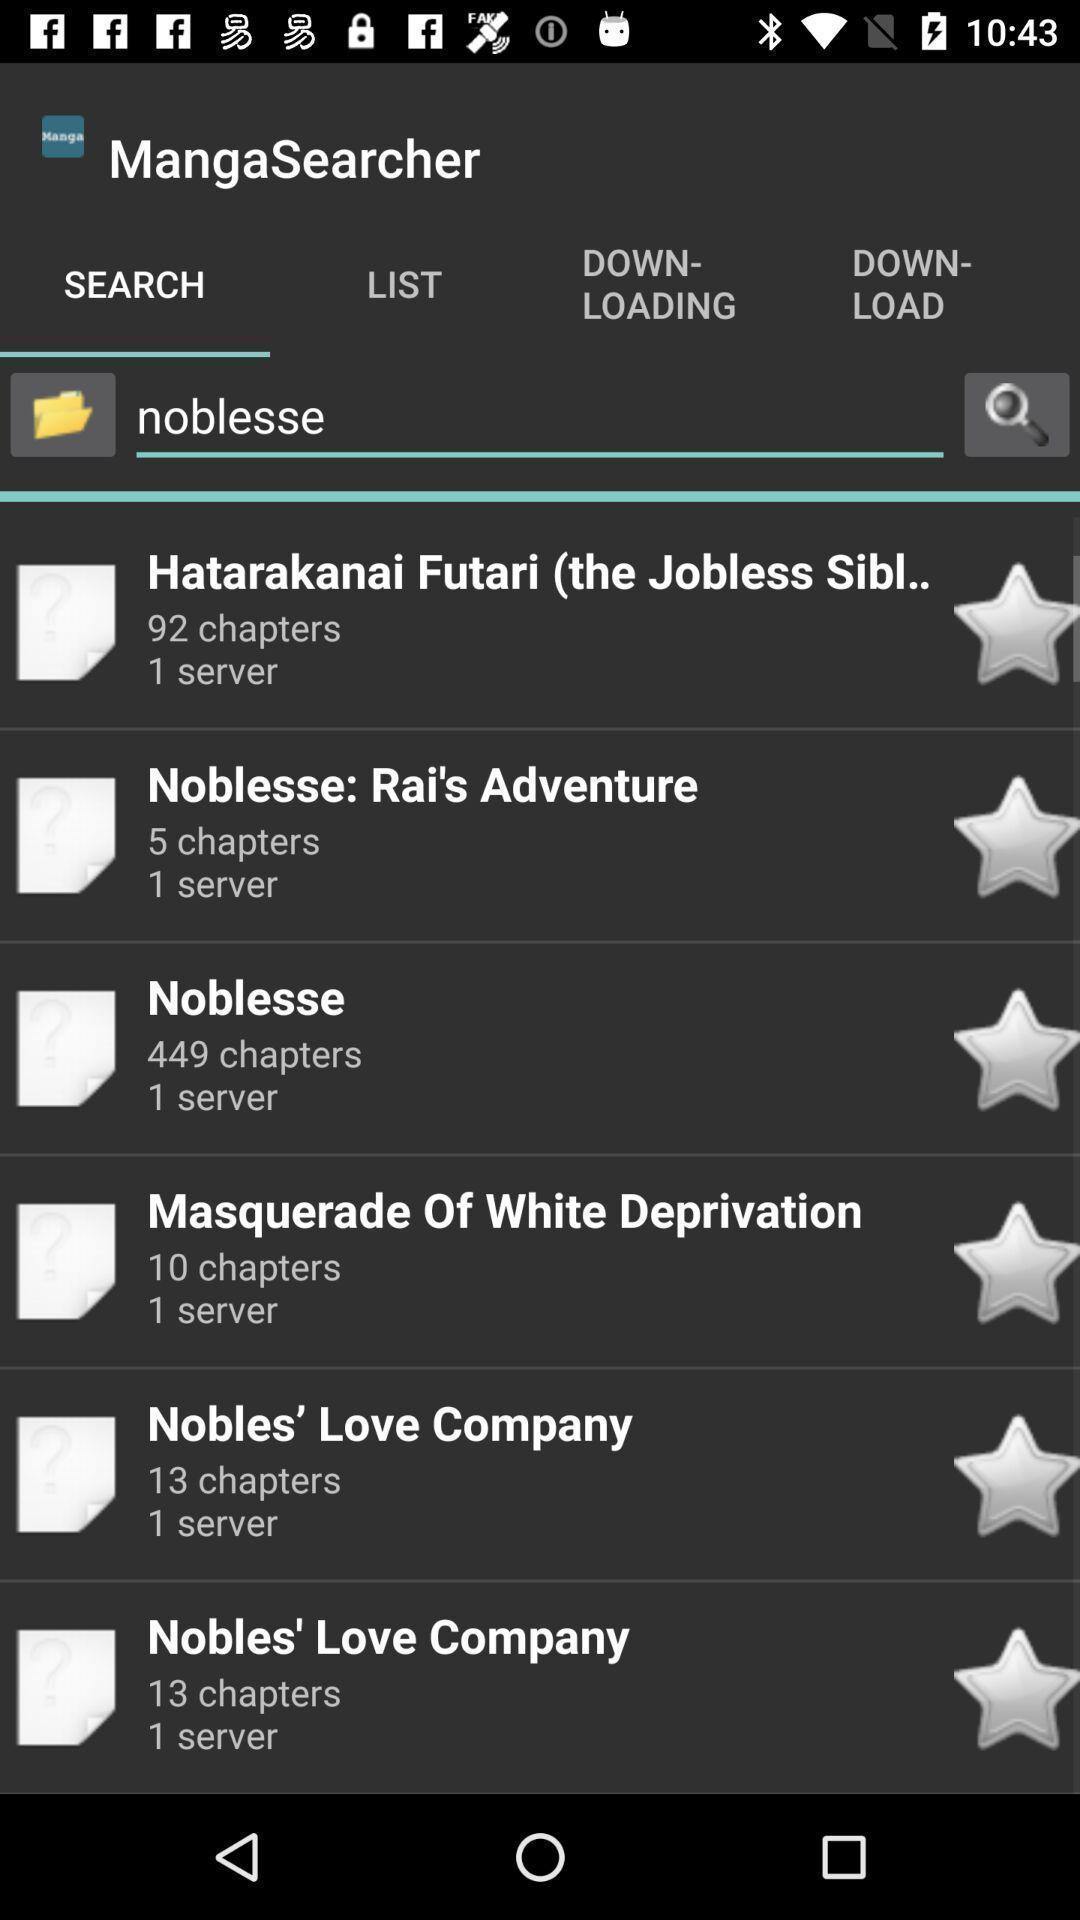Summarize the information in this screenshot. Search page for searching different story chapters. 